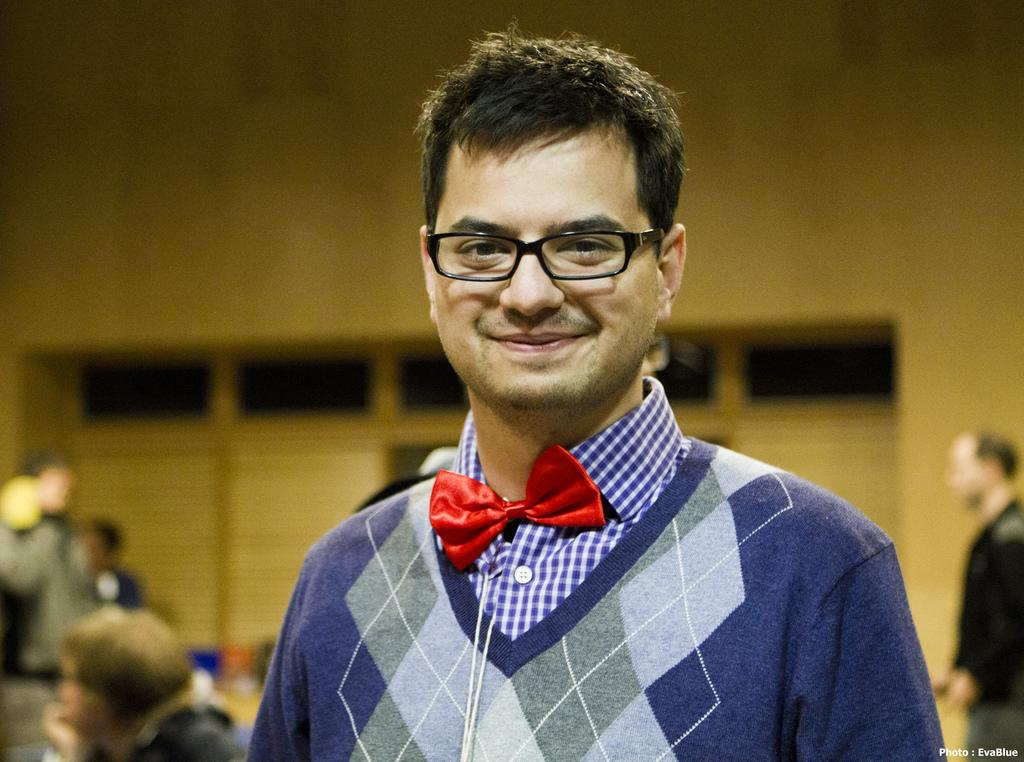What is the main subject in the foreground of the image? There is a man in the foreground of the image. What is the man doing in the image? The man is looking at someone. What can be observed about the man's appearance? The man is wearing glasses and has black hair. What type of zebra can be seen in the image? There is no zebra present in the image; it features a man looking at someone. What experience does the man have with solving riddles in the image? There is no information about the man's experience with solving riddles in the image. 